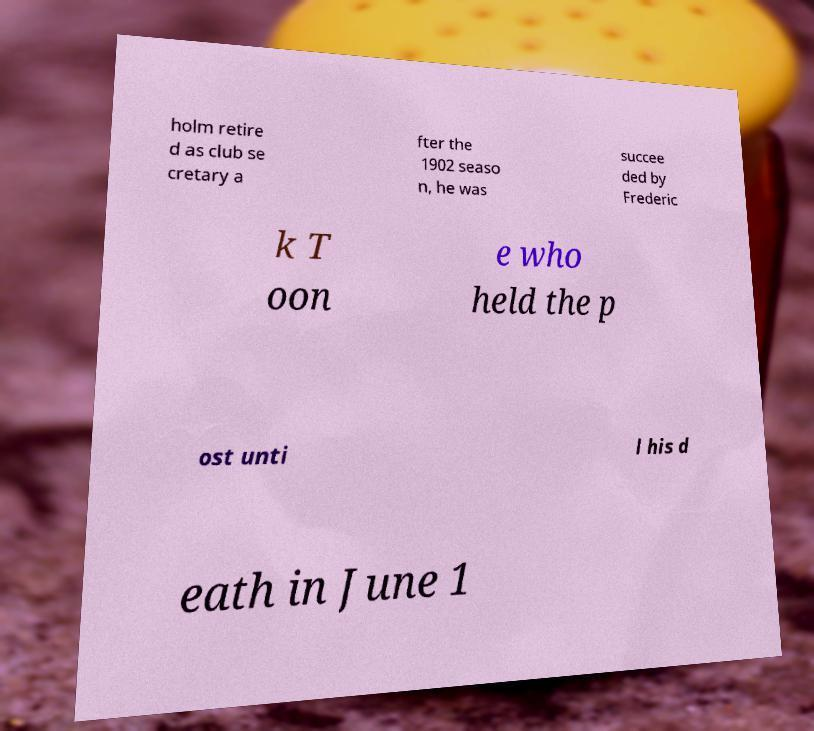Could you extract and type out the text from this image? holm retire d as club se cretary a fter the 1902 seaso n, he was succee ded by Frederic k T oon e who held the p ost unti l his d eath in June 1 